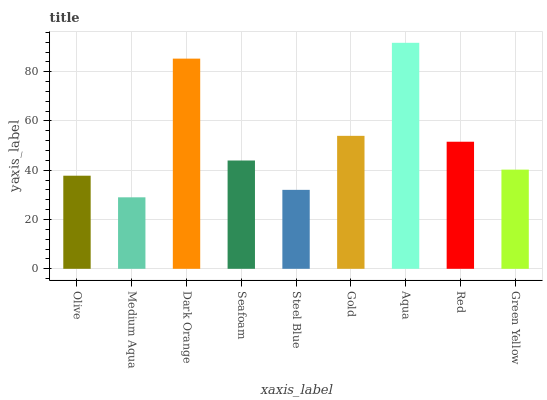Is Medium Aqua the minimum?
Answer yes or no. Yes. Is Aqua the maximum?
Answer yes or no. Yes. Is Dark Orange the minimum?
Answer yes or no. No. Is Dark Orange the maximum?
Answer yes or no. No. Is Dark Orange greater than Medium Aqua?
Answer yes or no. Yes. Is Medium Aqua less than Dark Orange?
Answer yes or no. Yes. Is Medium Aqua greater than Dark Orange?
Answer yes or no. No. Is Dark Orange less than Medium Aqua?
Answer yes or no. No. Is Seafoam the high median?
Answer yes or no. Yes. Is Seafoam the low median?
Answer yes or no. Yes. Is Olive the high median?
Answer yes or no. No. Is Steel Blue the low median?
Answer yes or no. No. 